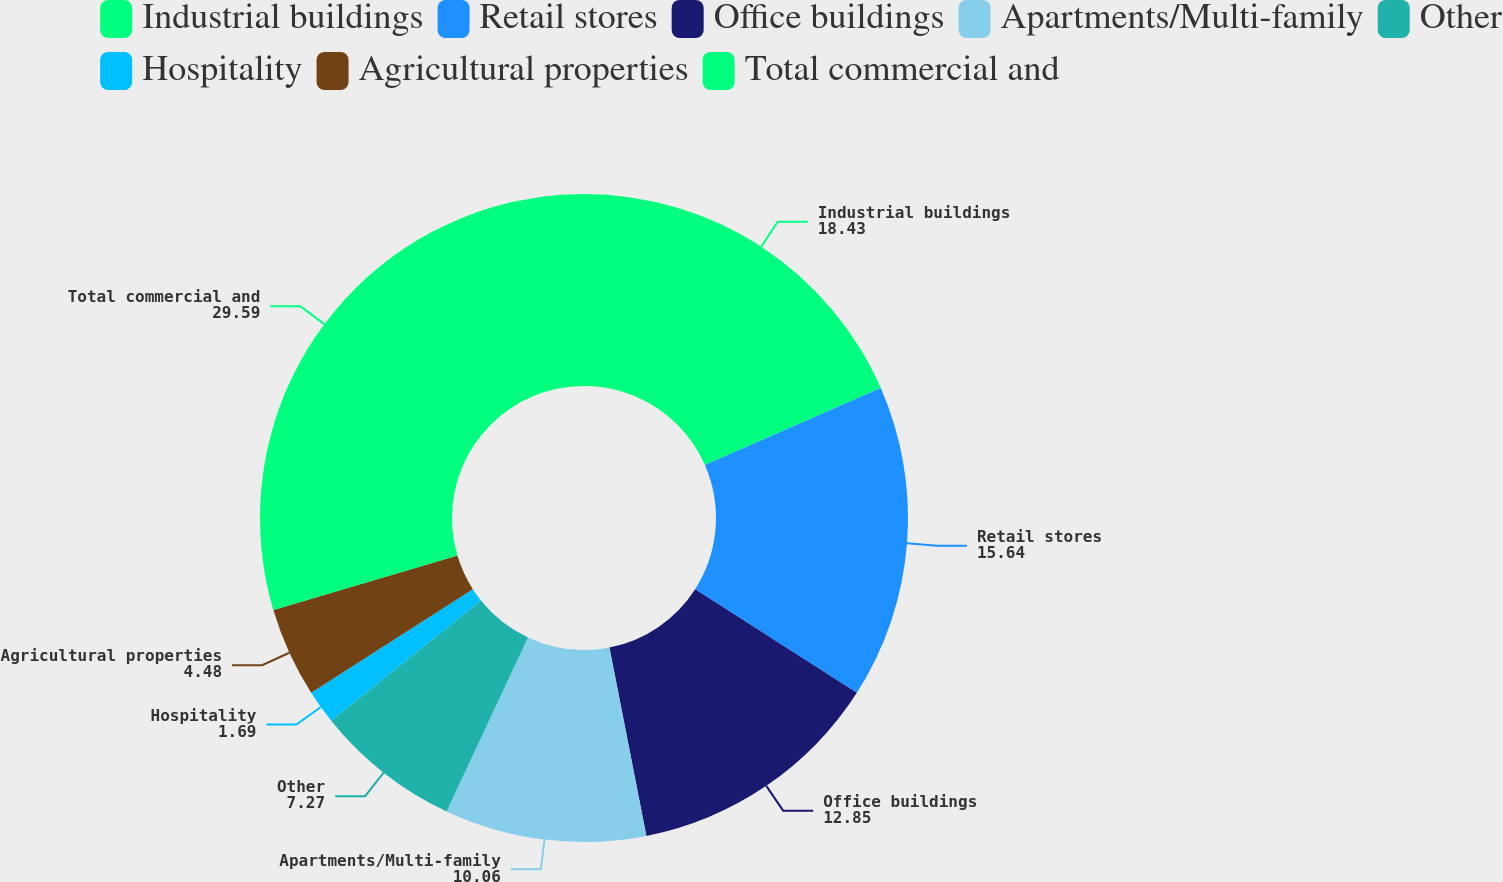Convert chart. <chart><loc_0><loc_0><loc_500><loc_500><pie_chart><fcel>Industrial buildings<fcel>Retail stores<fcel>Office buildings<fcel>Apartments/Multi-family<fcel>Other<fcel>Hospitality<fcel>Agricultural properties<fcel>Total commercial and<nl><fcel>18.43%<fcel>15.64%<fcel>12.85%<fcel>10.06%<fcel>7.27%<fcel>1.69%<fcel>4.48%<fcel>29.59%<nl></chart> 